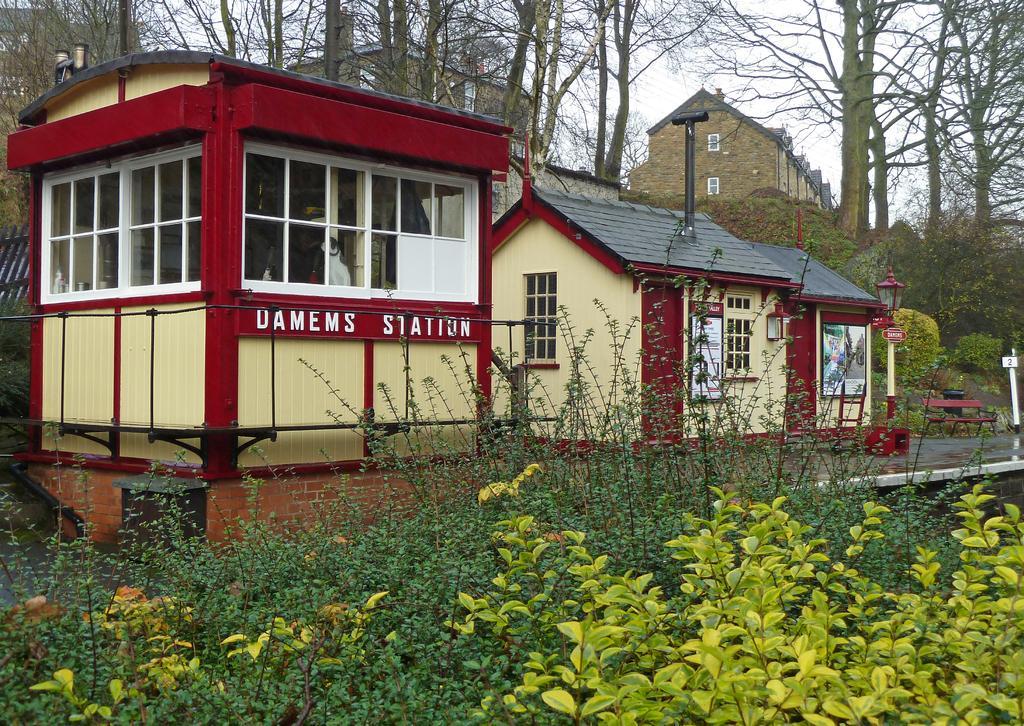How would you summarize this image in a sentence or two? In this image, we can see some homes, there are some green color plants, in the background there are some trees, at the top there is a sky. 